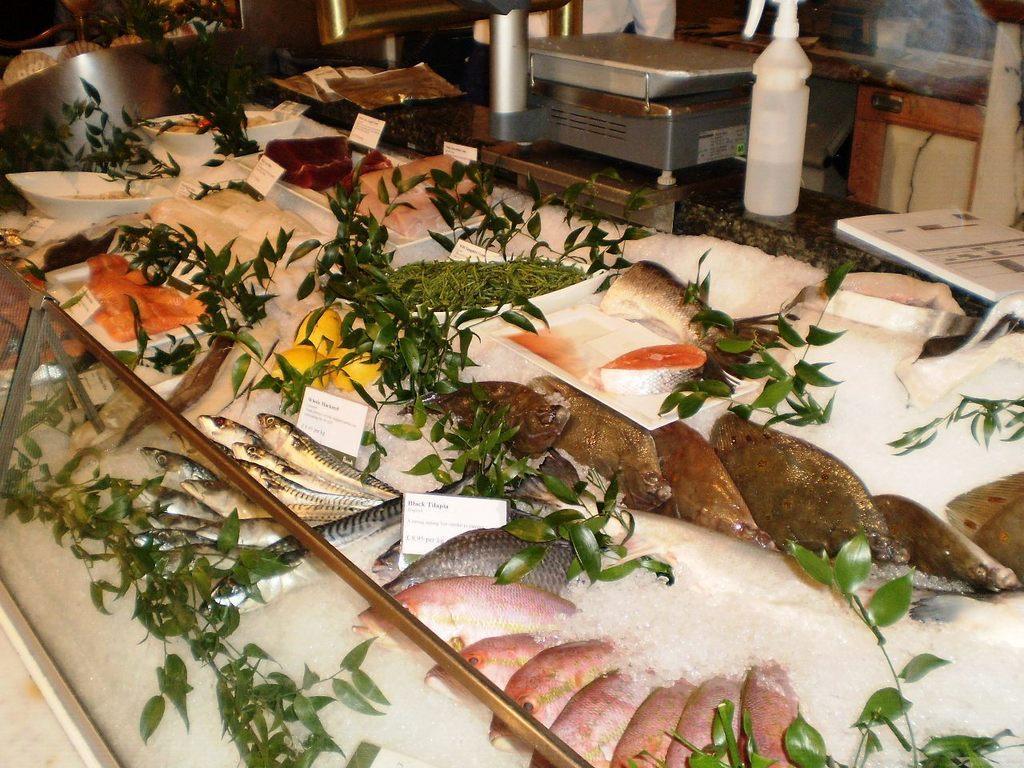In one or two sentences, can you explain what this image depicts? In the picture I can see plants, fishes, ice pieces in a glass object. In the background I can see some other things. 